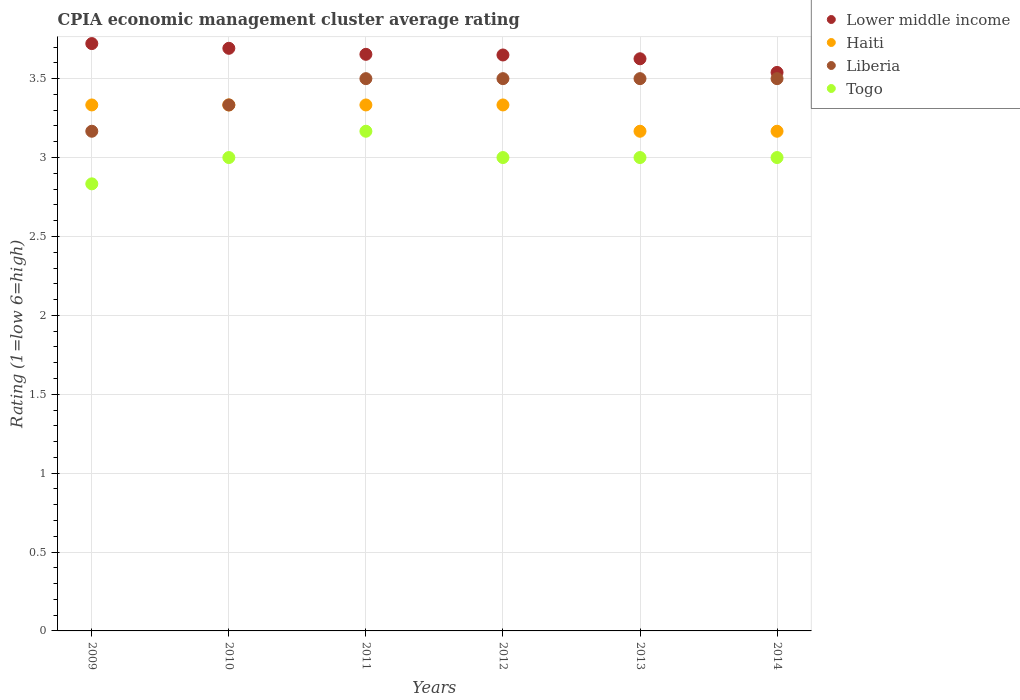Is the number of dotlines equal to the number of legend labels?
Offer a very short reply. Yes. What is the CPIA rating in Togo in 2014?
Ensure brevity in your answer.  3. Across all years, what is the maximum CPIA rating in Haiti?
Provide a succinct answer. 3.33. Across all years, what is the minimum CPIA rating in Lower middle income?
Offer a terse response. 3.54. What is the total CPIA rating in Liberia in the graph?
Offer a very short reply. 20.5. What is the difference between the CPIA rating in Togo in 2010 and that in 2013?
Give a very brief answer. 0. What is the difference between the CPIA rating in Lower middle income in 2011 and the CPIA rating in Haiti in 2013?
Provide a short and direct response. 0.49. What is the average CPIA rating in Haiti per year?
Keep it short and to the point. 3.28. In the year 2011, what is the difference between the CPIA rating in Liberia and CPIA rating in Haiti?
Give a very brief answer. 0.17. In how many years, is the CPIA rating in Togo greater than 1.4?
Keep it short and to the point. 6. What is the ratio of the CPIA rating in Lower middle income in 2013 to that in 2014?
Make the answer very short. 1.02. Is the CPIA rating in Liberia in 2010 less than that in 2011?
Make the answer very short. Yes. Is the difference between the CPIA rating in Liberia in 2011 and 2012 greater than the difference between the CPIA rating in Haiti in 2011 and 2012?
Your response must be concise. No. What is the difference between the highest and the second highest CPIA rating in Haiti?
Provide a short and direct response. 0. What is the difference between the highest and the lowest CPIA rating in Togo?
Keep it short and to the point. 0.33. Is it the case that in every year, the sum of the CPIA rating in Haiti and CPIA rating in Liberia  is greater than the sum of CPIA rating in Togo and CPIA rating in Lower middle income?
Provide a succinct answer. No. Is it the case that in every year, the sum of the CPIA rating in Togo and CPIA rating in Liberia  is greater than the CPIA rating in Lower middle income?
Keep it short and to the point. Yes. Is the CPIA rating in Haiti strictly greater than the CPIA rating in Lower middle income over the years?
Make the answer very short. No. How many dotlines are there?
Your answer should be very brief. 4. What is the difference between two consecutive major ticks on the Y-axis?
Your response must be concise. 0.5. Are the values on the major ticks of Y-axis written in scientific E-notation?
Your answer should be very brief. No. Does the graph contain grids?
Give a very brief answer. Yes. Where does the legend appear in the graph?
Make the answer very short. Top right. How many legend labels are there?
Your response must be concise. 4. What is the title of the graph?
Ensure brevity in your answer.  CPIA economic management cluster average rating. What is the label or title of the X-axis?
Your response must be concise. Years. What is the label or title of the Y-axis?
Your response must be concise. Rating (1=low 6=high). What is the Rating (1=low 6=high) in Lower middle income in 2009?
Keep it short and to the point. 3.72. What is the Rating (1=low 6=high) of Haiti in 2009?
Provide a succinct answer. 3.33. What is the Rating (1=low 6=high) of Liberia in 2009?
Provide a succinct answer. 3.17. What is the Rating (1=low 6=high) in Togo in 2009?
Offer a very short reply. 2.83. What is the Rating (1=low 6=high) in Lower middle income in 2010?
Provide a short and direct response. 3.69. What is the Rating (1=low 6=high) in Haiti in 2010?
Give a very brief answer. 3.33. What is the Rating (1=low 6=high) of Liberia in 2010?
Your response must be concise. 3.33. What is the Rating (1=low 6=high) of Togo in 2010?
Offer a very short reply. 3. What is the Rating (1=low 6=high) in Lower middle income in 2011?
Give a very brief answer. 3.65. What is the Rating (1=low 6=high) of Haiti in 2011?
Provide a short and direct response. 3.33. What is the Rating (1=low 6=high) of Liberia in 2011?
Give a very brief answer. 3.5. What is the Rating (1=low 6=high) of Togo in 2011?
Ensure brevity in your answer.  3.17. What is the Rating (1=low 6=high) of Lower middle income in 2012?
Offer a very short reply. 3.65. What is the Rating (1=low 6=high) of Haiti in 2012?
Make the answer very short. 3.33. What is the Rating (1=low 6=high) of Togo in 2012?
Make the answer very short. 3. What is the Rating (1=low 6=high) in Lower middle income in 2013?
Ensure brevity in your answer.  3.63. What is the Rating (1=low 6=high) of Haiti in 2013?
Provide a short and direct response. 3.17. What is the Rating (1=low 6=high) in Lower middle income in 2014?
Your response must be concise. 3.54. What is the Rating (1=low 6=high) in Haiti in 2014?
Offer a very short reply. 3.17. What is the Rating (1=low 6=high) in Liberia in 2014?
Keep it short and to the point. 3.5. Across all years, what is the maximum Rating (1=low 6=high) of Lower middle income?
Provide a succinct answer. 3.72. Across all years, what is the maximum Rating (1=low 6=high) in Haiti?
Ensure brevity in your answer.  3.33. Across all years, what is the maximum Rating (1=low 6=high) in Liberia?
Give a very brief answer. 3.5. Across all years, what is the maximum Rating (1=low 6=high) of Togo?
Provide a short and direct response. 3.17. Across all years, what is the minimum Rating (1=low 6=high) of Lower middle income?
Offer a very short reply. 3.54. Across all years, what is the minimum Rating (1=low 6=high) of Haiti?
Your answer should be compact. 3.17. Across all years, what is the minimum Rating (1=low 6=high) of Liberia?
Keep it short and to the point. 3.17. Across all years, what is the minimum Rating (1=low 6=high) of Togo?
Your response must be concise. 2.83. What is the total Rating (1=low 6=high) in Lower middle income in the graph?
Make the answer very short. 21.88. What is the total Rating (1=low 6=high) in Haiti in the graph?
Offer a terse response. 19.67. What is the total Rating (1=low 6=high) in Liberia in the graph?
Offer a very short reply. 20.5. What is the difference between the Rating (1=low 6=high) in Lower middle income in 2009 and that in 2010?
Your response must be concise. 0.03. What is the difference between the Rating (1=low 6=high) in Liberia in 2009 and that in 2010?
Provide a succinct answer. -0.17. What is the difference between the Rating (1=low 6=high) in Togo in 2009 and that in 2010?
Ensure brevity in your answer.  -0.17. What is the difference between the Rating (1=low 6=high) of Lower middle income in 2009 and that in 2011?
Make the answer very short. 0.07. What is the difference between the Rating (1=low 6=high) of Liberia in 2009 and that in 2011?
Ensure brevity in your answer.  -0.33. What is the difference between the Rating (1=low 6=high) in Togo in 2009 and that in 2011?
Keep it short and to the point. -0.33. What is the difference between the Rating (1=low 6=high) of Lower middle income in 2009 and that in 2012?
Provide a short and direct response. 0.07. What is the difference between the Rating (1=low 6=high) of Haiti in 2009 and that in 2012?
Your answer should be compact. 0. What is the difference between the Rating (1=low 6=high) of Togo in 2009 and that in 2012?
Offer a very short reply. -0.17. What is the difference between the Rating (1=low 6=high) of Lower middle income in 2009 and that in 2013?
Give a very brief answer. 0.1. What is the difference between the Rating (1=low 6=high) in Liberia in 2009 and that in 2013?
Make the answer very short. -0.33. What is the difference between the Rating (1=low 6=high) in Togo in 2009 and that in 2013?
Give a very brief answer. -0.17. What is the difference between the Rating (1=low 6=high) in Lower middle income in 2009 and that in 2014?
Your answer should be compact. 0.18. What is the difference between the Rating (1=low 6=high) of Lower middle income in 2010 and that in 2011?
Offer a terse response. 0.04. What is the difference between the Rating (1=low 6=high) of Haiti in 2010 and that in 2011?
Your answer should be very brief. 0. What is the difference between the Rating (1=low 6=high) in Liberia in 2010 and that in 2011?
Your answer should be compact. -0.17. What is the difference between the Rating (1=low 6=high) of Lower middle income in 2010 and that in 2012?
Provide a succinct answer. 0.04. What is the difference between the Rating (1=low 6=high) of Liberia in 2010 and that in 2012?
Provide a succinct answer. -0.17. What is the difference between the Rating (1=low 6=high) of Togo in 2010 and that in 2012?
Give a very brief answer. 0. What is the difference between the Rating (1=low 6=high) in Lower middle income in 2010 and that in 2013?
Keep it short and to the point. 0.07. What is the difference between the Rating (1=low 6=high) in Liberia in 2010 and that in 2013?
Your response must be concise. -0.17. What is the difference between the Rating (1=low 6=high) in Togo in 2010 and that in 2013?
Your response must be concise. 0. What is the difference between the Rating (1=low 6=high) of Lower middle income in 2010 and that in 2014?
Ensure brevity in your answer.  0.15. What is the difference between the Rating (1=low 6=high) of Haiti in 2010 and that in 2014?
Your response must be concise. 0.17. What is the difference between the Rating (1=low 6=high) of Lower middle income in 2011 and that in 2012?
Your answer should be compact. 0. What is the difference between the Rating (1=low 6=high) in Haiti in 2011 and that in 2012?
Your answer should be compact. 0. What is the difference between the Rating (1=low 6=high) in Lower middle income in 2011 and that in 2013?
Give a very brief answer. 0.03. What is the difference between the Rating (1=low 6=high) of Haiti in 2011 and that in 2013?
Offer a terse response. 0.17. What is the difference between the Rating (1=low 6=high) in Liberia in 2011 and that in 2013?
Your answer should be compact. 0. What is the difference between the Rating (1=low 6=high) of Togo in 2011 and that in 2013?
Ensure brevity in your answer.  0.17. What is the difference between the Rating (1=low 6=high) in Lower middle income in 2011 and that in 2014?
Offer a terse response. 0.11. What is the difference between the Rating (1=low 6=high) in Lower middle income in 2012 and that in 2013?
Offer a terse response. 0.02. What is the difference between the Rating (1=low 6=high) in Togo in 2012 and that in 2013?
Your response must be concise. 0. What is the difference between the Rating (1=low 6=high) in Lower middle income in 2012 and that in 2014?
Ensure brevity in your answer.  0.11. What is the difference between the Rating (1=low 6=high) in Liberia in 2012 and that in 2014?
Keep it short and to the point. 0. What is the difference between the Rating (1=low 6=high) of Togo in 2012 and that in 2014?
Ensure brevity in your answer.  0. What is the difference between the Rating (1=low 6=high) of Lower middle income in 2013 and that in 2014?
Provide a short and direct response. 0.09. What is the difference between the Rating (1=low 6=high) in Haiti in 2013 and that in 2014?
Your answer should be compact. -0. What is the difference between the Rating (1=low 6=high) in Lower middle income in 2009 and the Rating (1=low 6=high) in Haiti in 2010?
Keep it short and to the point. 0.39. What is the difference between the Rating (1=low 6=high) of Lower middle income in 2009 and the Rating (1=low 6=high) of Liberia in 2010?
Make the answer very short. 0.39. What is the difference between the Rating (1=low 6=high) of Lower middle income in 2009 and the Rating (1=low 6=high) of Togo in 2010?
Provide a succinct answer. 0.72. What is the difference between the Rating (1=low 6=high) of Haiti in 2009 and the Rating (1=low 6=high) of Togo in 2010?
Provide a succinct answer. 0.33. What is the difference between the Rating (1=low 6=high) in Lower middle income in 2009 and the Rating (1=low 6=high) in Haiti in 2011?
Offer a terse response. 0.39. What is the difference between the Rating (1=low 6=high) in Lower middle income in 2009 and the Rating (1=low 6=high) in Liberia in 2011?
Make the answer very short. 0.22. What is the difference between the Rating (1=low 6=high) in Lower middle income in 2009 and the Rating (1=low 6=high) in Togo in 2011?
Your response must be concise. 0.56. What is the difference between the Rating (1=low 6=high) in Lower middle income in 2009 and the Rating (1=low 6=high) in Haiti in 2012?
Your answer should be compact. 0.39. What is the difference between the Rating (1=low 6=high) of Lower middle income in 2009 and the Rating (1=low 6=high) of Liberia in 2012?
Your answer should be compact. 0.22. What is the difference between the Rating (1=low 6=high) in Lower middle income in 2009 and the Rating (1=low 6=high) in Togo in 2012?
Give a very brief answer. 0.72. What is the difference between the Rating (1=low 6=high) in Haiti in 2009 and the Rating (1=low 6=high) in Liberia in 2012?
Give a very brief answer. -0.17. What is the difference between the Rating (1=low 6=high) of Haiti in 2009 and the Rating (1=low 6=high) of Togo in 2012?
Keep it short and to the point. 0.33. What is the difference between the Rating (1=low 6=high) of Lower middle income in 2009 and the Rating (1=low 6=high) of Haiti in 2013?
Provide a succinct answer. 0.56. What is the difference between the Rating (1=low 6=high) in Lower middle income in 2009 and the Rating (1=low 6=high) in Liberia in 2013?
Provide a short and direct response. 0.22. What is the difference between the Rating (1=low 6=high) in Lower middle income in 2009 and the Rating (1=low 6=high) in Togo in 2013?
Provide a succinct answer. 0.72. What is the difference between the Rating (1=low 6=high) of Haiti in 2009 and the Rating (1=low 6=high) of Liberia in 2013?
Your response must be concise. -0.17. What is the difference between the Rating (1=low 6=high) of Liberia in 2009 and the Rating (1=low 6=high) of Togo in 2013?
Offer a terse response. 0.17. What is the difference between the Rating (1=low 6=high) of Lower middle income in 2009 and the Rating (1=low 6=high) of Haiti in 2014?
Your response must be concise. 0.56. What is the difference between the Rating (1=low 6=high) in Lower middle income in 2009 and the Rating (1=low 6=high) in Liberia in 2014?
Offer a very short reply. 0.22. What is the difference between the Rating (1=low 6=high) in Lower middle income in 2009 and the Rating (1=low 6=high) in Togo in 2014?
Your response must be concise. 0.72. What is the difference between the Rating (1=low 6=high) of Lower middle income in 2010 and the Rating (1=low 6=high) of Haiti in 2011?
Your answer should be very brief. 0.36. What is the difference between the Rating (1=low 6=high) of Lower middle income in 2010 and the Rating (1=low 6=high) of Liberia in 2011?
Keep it short and to the point. 0.19. What is the difference between the Rating (1=low 6=high) in Lower middle income in 2010 and the Rating (1=low 6=high) in Togo in 2011?
Your answer should be very brief. 0.53. What is the difference between the Rating (1=low 6=high) of Haiti in 2010 and the Rating (1=low 6=high) of Liberia in 2011?
Provide a short and direct response. -0.17. What is the difference between the Rating (1=low 6=high) of Haiti in 2010 and the Rating (1=low 6=high) of Togo in 2011?
Provide a succinct answer. 0.17. What is the difference between the Rating (1=low 6=high) in Lower middle income in 2010 and the Rating (1=low 6=high) in Haiti in 2012?
Keep it short and to the point. 0.36. What is the difference between the Rating (1=low 6=high) of Lower middle income in 2010 and the Rating (1=low 6=high) of Liberia in 2012?
Make the answer very short. 0.19. What is the difference between the Rating (1=low 6=high) of Lower middle income in 2010 and the Rating (1=low 6=high) of Togo in 2012?
Keep it short and to the point. 0.69. What is the difference between the Rating (1=low 6=high) of Lower middle income in 2010 and the Rating (1=low 6=high) of Haiti in 2013?
Offer a terse response. 0.53. What is the difference between the Rating (1=low 6=high) in Lower middle income in 2010 and the Rating (1=low 6=high) in Liberia in 2013?
Keep it short and to the point. 0.19. What is the difference between the Rating (1=low 6=high) in Lower middle income in 2010 and the Rating (1=low 6=high) in Togo in 2013?
Ensure brevity in your answer.  0.69. What is the difference between the Rating (1=low 6=high) in Lower middle income in 2010 and the Rating (1=low 6=high) in Haiti in 2014?
Your answer should be very brief. 0.53. What is the difference between the Rating (1=low 6=high) in Lower middle income in 2010 and the Rating (1=low 6=high) in Liberia in 2014?
Provide a short and direct response. 0.19. What is the difference between the Rating (1=low 6=high) in Lower middle income in 2010 and the Rating (1=low 6=high) in Togo in 2014?
Your answer should be compact. 0.69. What is the difference between the Rating (1=low 6=high) in Haiti in 2010 and the Rating (1=low 6=high) in Togo in 2014?
Your answer should be very brief. 0.33. What is the difference between the Rating (1=low 6=high) in Lower middle income in 2011 and the Rating (1=low 6=high) in Haiti in 2012?
Keep it short and to the point. 0.32. What is the difference between the Rating (1=low 6=high) of Lower middle income in 2011 and the Rating (1=low 6=high) of Liberia in 2012?
Provide a short and direct response. 0.15. What is the difference between the Rating (1=low 6=high) in Lower middle income in 2011 and the Rating (1=low 6=high) in Togo in 2012?
Provide a succinct answer. 0.65. What is the difference between the Rating (1=low 6=high) in Lower middle income in 2011 and the Rating (1=low 6=high) in Haiti in 2013?
Give a very brief answer. 0.49. What is the difference between the Rating (1=low 6=high) in Lower middle income in 2011 and the Rating (1=low 6=high) in Liberia in 2013?
Keep it short and to the point. 0.15. What is the difference between the Rating (1=low 6=high) of Lower middle income in 2011 and the Rating (1=low 6=high) of Togo in 2013?
Keep it short and to the point. 0.65. What is the difference between the Rating (1=low 6=high) of Liberia in 2011 and the Rating (1=low 6=high) of Togo in 2013?
Make the answer very short. 0.5. What is the difference between the Rating (1=low 6=high) of Lower middle income in 2011 and the Rating (1=low 6=high) of Haiti in 2014?
Offer a very short reply. 0.49. What is the difference between the Rating (1=low 6=high) in Lower middle income in 2011 and the Rating (1=low 6=high) in Liberia in 2014?
Offer a very short reply. 0.15. What is the difference between the Rating (1=low 6=high) in Lower middle income in 2011 and the Rating (1=low 6=high) in Togo in 2014?
Make the answer very short. 0.65. What is the difference between the Rating (1=low 6=high) in Haiti in 2011 and the Rating (1=low 6=high) in Togo in 2014?
Make the answer very short. 0.33. What is the difference between the Rating (1=low 6=high) in Liberia in 2011 and the Rating (1=low 6=high) in Togo in 2014?
Offer a very short reply. 0.5. What is the difference between the Rating (1=low 6=high) in Lower middle income in 2012 and the Rating (1=low 6=high) in Haiti in 2013?
Make the answer very short. 0.48. What is the difference between the Rating (1=low 6=high) of Lower middle income in 2012 and the Rating (1=low 6=high) of Liberia in 2013?
Provide a succinct answer. 0.15. What is the difference between the Rating (1=low 6=high) of Lower middle income in 2012 and the Rating (1=low 6=high) of Togo in 2013?
Make the answer very short. 0.65. What is the difference between the Rating (1=low 6=high) in Haiti in 2012 and the Rating (1=low 6=high) in Liberia in 2013?
Your answer should be very brief. -0.17. What is the difference between the Rating (1=low 6=high) of Haiti in 2012 and the Rating (1=low 6=high) of Togo in 2013?
Your response must be concise. 0.33. What is the difference between the Rating (1=low 6=high) in Lower middle income in 2012 and the Rating (1=low 6=high) in Haiti in 2014?
Keep it short and to the point. 0.48. What is the difference between the Rating (1=low 6=high) of Lower middle income in 2012 and the Rating (1=low 6=high) of Liberia in 2014?
Your answer should be very brief. 0.15. What is the difference between the Rating (1=low 6=high) in Lower middle income in 2012 and the Rating (1=low 6=high) in Togo in 2014?
Ensure brevity in your answer.  0.65. What is the difference between the Rating (1=low 6=high) of Haiti in 2012 and the Rating (1=low 6=high) of Togo in 2014?
Provide a succinct answer. 0.33. What is the difference between the Rating (1=low 6=high) in Lower middle income in 2013 and the Rating (1=low 6=high) in Haiti in 2014?
Provide a succinct answer. 0.46. What is the difference between the Rating (1=low 6=high) in Lower middle income in 2013 and the Rating (1=low 6=high) in Liberia in 2014?
Your answer should be very brief. 0.13. What is the difference between the Rating (1=low 6=high) of Lower middle income in 2013 and the Rating (1=low 6=high) of Togo in 2014?
Offer a terse response. 0.63. What is the difference between the Rating (1=low 6=high) in Haiti in 2013 and the Rating (1=low 6=high) in Togo in 2014?
Offer a terse response. 0.17. What is the difference between the Rating (1=low 6=high) in Liberia in 2013 and the Rating (1=low 6=high) in Togo in 2014?
Make the answer very short. 0.5. What is the average Rating (1=low 6=high) of Lower middle income per year?
Make the answer very short. 3.65. What is the average Rating (1=low 6=high) in Haiti per year?
Your answer should be compact. 3.28. What is the average Rating (1=low 6=high) of Liberia per year?
Keep it short and to the point. 3.42. In the year 2009, what is the difference between the Rating (1=low 6=high) in Lower middle income and Rating (1=low 6=high) in Haiti?
Provide a succinct answer. 0.39. In the year 2009, what is the difference between the Rating (1=low 6=high) in Lower middle income and Rating (1=low 6=high) in Liberia?
Make the answer very short. 0.56. In the year 2009, what is the difference between the Rating (1=low 6=high) of Lower middle income and Rating (1=low 6=high) of Togo?
Your answer should be very brief. 0.89. In the year 2009, what is the difference between the Rating (1=low 6=high) in Haiti and Rating (1=low 6=high) in Liberia?
Give a very brief answer. 0.17. In the year 2009, what is the difference between the Rating (1=low 6=high) of Haiti and Rating (1=low 6=high) of Togo?
Your answer should be compact. 0.5. In the year 2010, what is the difference between the Rating (1=low 6=high) in Lower middle income and Rating (1=low 6=high) in Haiti?
Ensure brevity in your answer.  0.36. In the year 2010, what is the difference between the Rating (1=low 6=high) of Lower middle income and Rating (1=low 6=high) of Liberia?
Keep it short and to the point. 0.36. In the year 2010, what is the difference between the Rating (1=low 6=high) in Lower middle income and Rating (1=low 6=high) in Togo?
Ensure brevity in your answer.  0.69. In the year 2010, what is the difference between the Rating (1=low 6=high) in Haiti and Rating (1=low 6=high) in Liberia?
Give a very brief answer. 0. In the year 2010, what is the difference between the Rating (1=low 6=high) in Liberia and Rating (1=low 6=high) in Togo?
Your answer should be very brief. 0.33. In the year 2011, what is the difference between the Rating (1=low 6=high) in Lower middle income and Rating (1=low 6=high) in Haiti?
Your answer should be very brief. 0.32. In the year 2011, what is the difference between the Rating (1=low 6=high) in Lower middle income and Rating (1=low 6=high) in Liberia?
Make the answer very short. 0.15. In the year 2011, what is the difference between the Rating (1=low 6=high) in Lower middle income and Rating (1=low 6=high) in Togo?
Provide a short and direct response. 0.49. In the year 2011, what is the difference between the Rating (1=low 6=high) in Haiti and Rating (1=low 6=high) in Togo?
Your response must be concise. 0.17. In the year 2011, what is the difference between the Rating (1=low 6=high) of Liberia and Rating (1=low 6=high) of Togo?
Offer a terse response. 0.33. In the year 2012, what is the difference between the Rating (1=low 6=high) of Lower middle income and Rating (1=low 6=high) of Haiti?
Your answer should be compact. 0.32. In the year 2012, what is the difference between the Rating (1=low 6=high) of Lower middle income and Rating (1=low 6=high) of Liberia?
Give a very brief answer. 0.15. In the year 2012, what is the difference between the Rating (1=low 6=high) of Lower middle income and Rating (1=low 6=high) of Togo?
Make the answer very short. 0.65. In the year 2012, what is the difference between the Rating (1=low 6=high) of Haiti and Rating (1=low 6=high) of Togo?
Offer a terse response. 0.33. In the year 2013, what is the difference between the Rating (1=low 6=high) in Lower middle income and Rating (1=low 6=high) in Haiti?
Ensure brevity in your answer.  0.46. In the year 2013, what is the difference between the Rating (1=low 6=high) of Lower middle income and Rating (1=low 6=high) of Liberia?
Your answer should be very brief. 0.13. In the year 2013, what is the difference between the Rating (1=low 6=high) of Lower middle income and Rating (1=low 6=high) of Togo?
Your answer should be compact. 0.63. In the year 2013, what is the difference between the Rating (1=low 6=high) of Haiti and Rating (1=low 6=high) of Liberia?
Your answer should be very brief. -0.33. In the year 2014, what is the difference between the Rating (1=low 6=high) in Lower middle income and Rating (1=low 6=high) in Haiti?
Keep it short and to the point. 0.37. In the year 2014, what is the difference between the Rating (1=low 6=high) in Lower middle income and Rating (1=low 6=high) in Liberia?
Your answer should be very brief. 0.04. In the year 2014, what is the difference between the Rating (1=low 6=high) in Lower middle income and Rating (1=low 6=high) in Togo?
Ensure brevity in your answer.  0.54. In the year 2014, what is the difference between the Rating (1=low 6=high) of Liberia and Rating (1=low 6=high) of Togo?
Your answer should be compact. 0.5. What is the ratio of the Rating (1=low 6=high) in Haiti in 2009 to that in 2010?
Give a very brief answer. 1. What is the ratio of the Rating (1=low 6=high) in Liberia in 2009 to that in 2010?
Offer a terse response. 0.95. What is the ratio of the Rating (1=low 6=high) of Togo in 2009 to that in 2010?
Your answer should be compact. 0.94. What is the ratio of the Rating (1=low 6=high) in Lower middle income in 2009 to that in 2011?
Ensure brevity in your answer.  1.02. What is the ratio of the Rating (1=low 6=high) of Haiti in 2009 to that in 2011?
Your answer should be very brief. 1. What is the ratio of the Rating (1=low 6=high) in Liberia in 2009 to that in 2011?
Offer a very short reply. 0.9. What is the ratio of the Rating (1=low 6=high) of Togo in 2009 to that in 2011?
Ensure brevity in your answer.  0.89. What is the ratio of the Rating (1=low 6=high) in Lower middle income in 2009 to that in 2012?
Provide a short and direct response. 1.02. What is the ratio of the Rating (1=low 6=high) of Liberia in 2009 to that in 2012?
Your answer should be compact. 0.9. What is the ratio of the Rating (1=low 6=high) in Togo in 2009 to that in 2012?
Your answer should be very brief. 0.94. What is the ratio of the Rating (1=low 6=high) of Lower middle income in 2009 to that in 2013?
Offer a very short reply. 1.03. What is the ratio of the Rating (1=low 6=high) of Haiti in 2009 to that in 2013?
Your answer should be compact. 1.05. What is the ratio of the Rating (1=low 6=high) in Liberia in 2009 to that in 2013?
Ensure brevity in your answer.  0.9. What is the ratio of the Rating (1=low 6=high) of Lower middle income in 2009 to that in 2014?
Keep it short and to the point. 1.05. What is the ratio of the Rating (1=low 6=high) in Haiti in 2009 to that in 2014?
Ensure brevity in your answer.  1.05. What is the ratio of the Rating (1=low 6=high) in Liberia in 2009 to that in 2014?
Your response must be concise. 0.9. What is the ratio of the Rating (1=low 6=high) in Togo in 2009 to that in 2014?
Your answer should be compact. 0.94. What is the ratio of the Rating (1=low 6=high) of Lower middle income in 2010 to that in 2011?
Provide a succinct answer. 1.01. What is the ratio of the Rating (1=low 6=high) of Liberia in 2010 to that in 2011?
Your answer should be very brief. 0.95. What is the ratio of the Rating (1=low 6=high) in Togo in 2010 to that in 2011?
Offer a very short reply. 0.95. What is the ratio of the Rating (1=low 6=high) of Lower middle income in 2010 to that in 2012?
Give a very brief answer. 1.01. What is the ratio of the Rating (1=low 6=high) of Liberia in 2010 to that in 2012?
Your answer should be very brief. 0.95. What is the ratio of the Rating (1=low 6=high) in Lower middle income in 2010 to that in 2013?
Offer a very short reply. 1.02. What is the ratio of the Rating (1=low 6=high) of Haiti in 2010 to that in 2013?
Offer a terse response. 1.05. What is the ratio of the Rating (1=low 6=high) of Liberia in 2010 to that in 2013?
Make the answer very short. 0.95. What is the ratio of the Rating (1=low 6=high) in Lower middle income in 2010 to that in 2014?
Your answer should be compact. 1.04. What is the ratio of the Rating (1=low 6=high) of Haiti in 2010 to that in 2014?
Offer a terse response. 1.05. What is the ratio of the Rating (1=low 6=high) of Lower middle income in 2011 to that in 2012?
Keep it short and to the point. 1. What is the ratio of the Rating (1=low 6=high) in Haiti in 2011 to that in 2012?
Provide a succinct answer. 1. What is the ratio of the Rating (1=low 6=high) of Togo in 2011 to that in 2012?
Offer a very short reply. 1.06. What is the ratio of the Rating (1=low 6=high) in Lower middle income in 2011 to that in 2013?
Your response must be concise. 1.01. What is the ratio of the Rating (1=low 6=high) of Haiti in 2011 to that in 2013?
Provide a succinct answer. 1.05. What is the ratio of the Rating (1=low 6=high) of Togo in 2011 to that in 2013?
Ensure brevity in your answer.  1.06. What is the ratio of the Rating (1=low 6=high) in Lower middle income in 2011 to that in 2014?
Give a very brief answer. 1.03. What is the ratio of the Rating (1=low 6=high) in Haiti in 2011 to that in 2014?
Your response must be concise. 1.05. What is the ratio of the Rating (1=low 6=high) of Liberia in 2011 to that in 2014?
Ensure brevity in your answer.  1. What is the ratio of the Rating (1=low 6=high) of Togo in 2011 to that in 2014?
Provide a short and direct response. 1.06. What is the ratio of the Rating (1=low 6=high) in Lower middle income in 2012 to that in 2013?
Make the answer very short. 1.01. What is the ratio of the Rating (1=low 6=high) in Haiti in 2012 to that in 2013?
Give a very brief answer. 1.05. What is the ratio of the Rating (1=low 6=high) in Togo in 2012 to that in 2013?
Offer a terse response. 1. What is the ratio of the Rating (1=low 6=high) in Lower middle income in 2012 to that in 2014?
Offer a very short reply. 1.03. What is the ratio of the Rating (1=low 6=high) of Haiti in 2012 to that in 2014?
Give a very brief answer. 1.05. What is the ratio of the Rating (1=low 6=high) of Togo in 2012 to that in 2014?
Ensure brevity in your answer.  1. What is the ratio of the Rating (1=low 6=high) of Lower middle income in 2013 to that in 2014?
Your response must be concise. 1.02. What is the ratio of the Rating (1=low 6=high) of Haiti in 2013 to that in 2014?
Make the answer very short. 1. What is the ratio of the Rating (1=low 6=high) of Liberia in 2013 to that in 2014?
Make the answer very short. 1. What is the ratio of the Rating (1=low 6=high) in Togo in 2013 to that in 2014?
Ensure brevity in your answer.  1. What is the difference between the highest and the second highest Rating (1=low 6=high) of Lower middle income?
Ensure brevity in your answer.  0.03. What is the difference between the highest and the second highest Rating (1=low 6=high) in Togo?
Ensure brevity in your answer.  0.17. What is the difference between the highest and the lowest Rating (1=low 6=high) of Lower middle income?
Make the answer very short. 0.18. What is the difference between the highest and the lowest Rating (1=low 6=high) of Haiti?
Ensure brevity in your answer.  0.17. What is the difference between the highest and the lowest Rating (1=low 6=high) in Togo?
Ensure brevity in your answer.  0.33. 